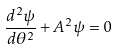Convert formula to latex. <formula><loc_0><loc_0><loc_500><loc_500>\frac { d ^ { 2 } \psi } { d \theta ^ { 2 } } + A ^ { 2 } \psi = 0</formula> 